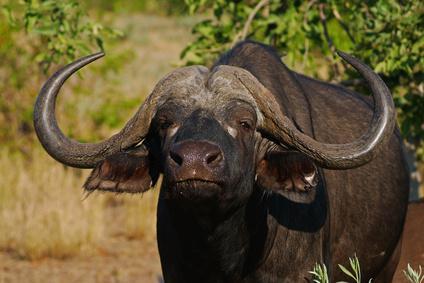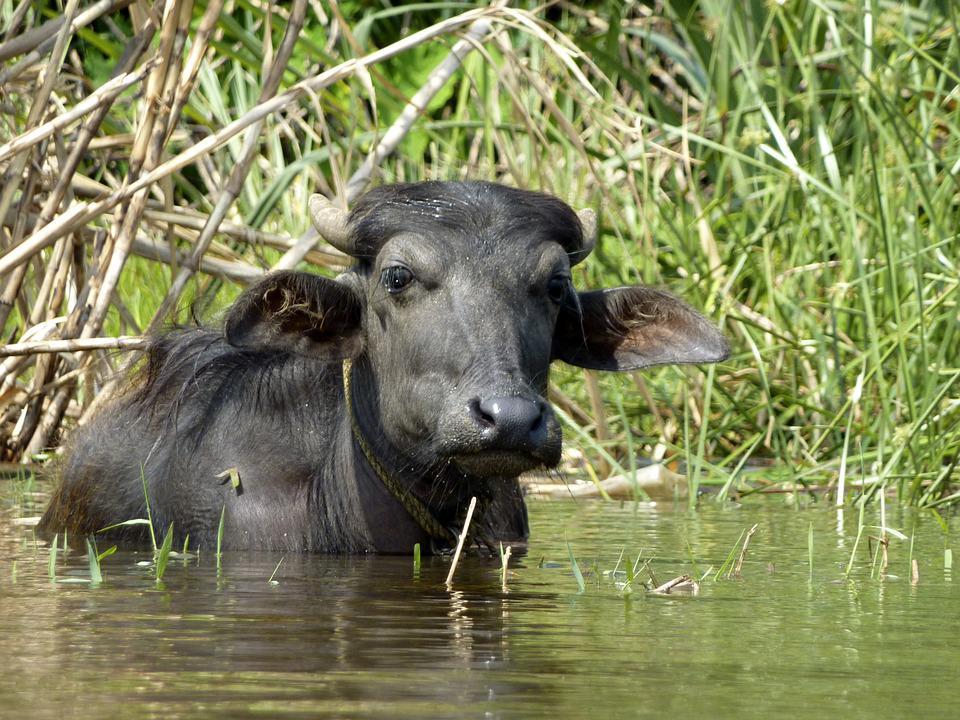The first image is the image on the left, the second image is the image on the right. Evaluate the accuracy of this statement regarding the images: "Exactly one image shows a water buffalo standing in water, and there is only one animal in the image.". Is it true? Answer yes or no. Yes. The first image is the image on the left, the second image is the image on the right. For the images displayed, is the sentence "At least one cow is standing chest deep in water." factually correct? Answer yes or no. Yes. 